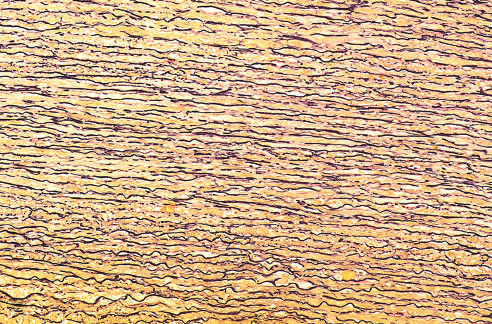s this stained black in the figure?
Answer the question using a single word or phrase. No 